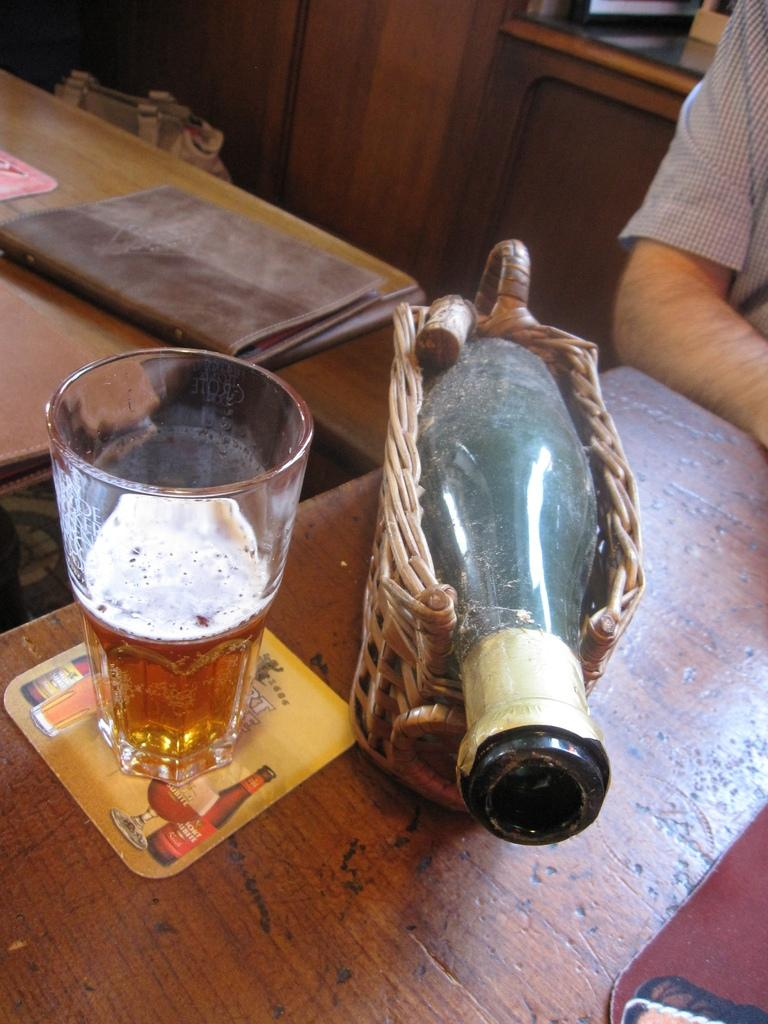What type of container is visible in the image? There is a glass and a bottle in the image. What is the color of the table on which the objects are placed? The table is brown in color. Who is present in the image? There is a person in the image. What can be used for reading or studying in the image? There is a book in the image. What type of furniture is present in the image? There is a cupboard in the image. How many beads are on the person's lip in the image? There are no beads or any reference to lips in the image. 